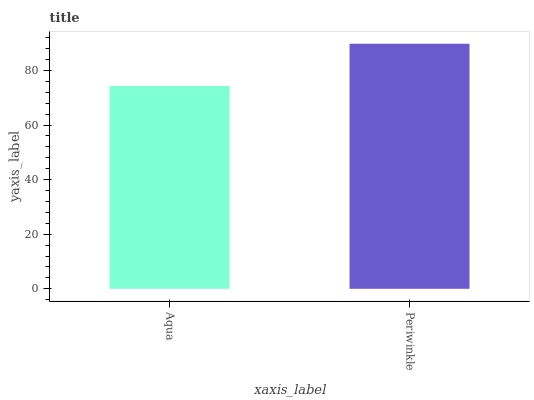Is Aqua the minimum?
Answer yes or no. Yes. Is Periwinkle the maximum?
Answer yes or no. Yes. Is Periwinkle the minimum?
Answer yes or no. No. Is Periwinkle greater than Aqua?
Answer yes or no. Yes. Is Aqua less than Periwinkle?
Answer yes or no. Yes. Is Aqua greater than Periwinkle?
Answer yes or no. No. Is Periwinkle less than Aqua?
Answer yes or no. No. Is Periwinkle the high median?
Answer yes or no. Yes. Is Aqua the low median?
Answer yes or no. Yes. Is Aqua the high median?
Answer yes or no. No. Is Periwinkle the low median?
Answer yes or no. No. 